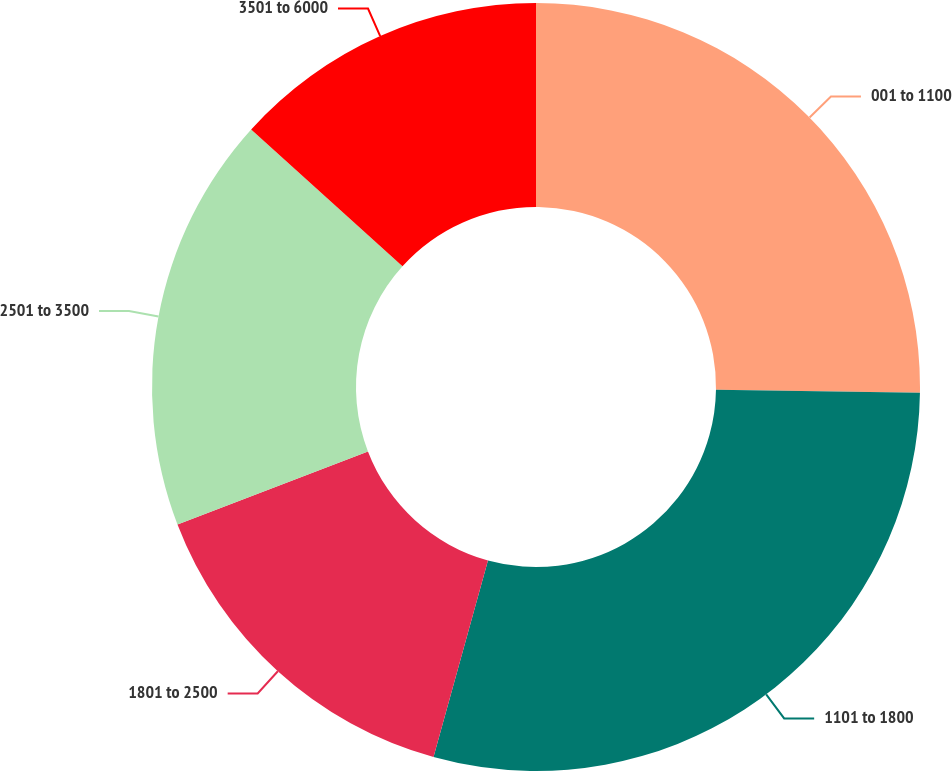Convert chart to OTSL. <chart><loc_0><loc_0><loc_500><loc_500><pie_chart><fcel>001 to 1100<fcel>1101 to 1800<fcel>1801 to 2500<fcel>2501 to 3500<fcel>3501 to 6000<nl><fcel>25.24%<fcel>29.06%<fcel>14.87%<fcel>17.53%<fcel>13.3%<nl></chart> 